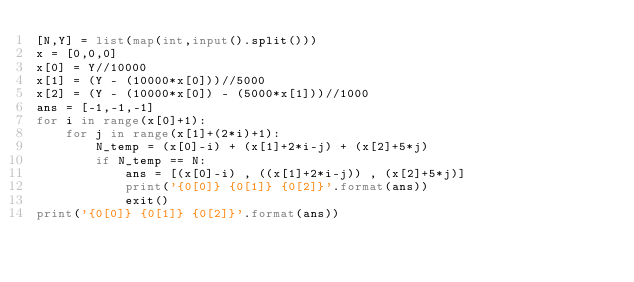<code> <loc_0><loc_0><loc_500><loc_500><_Python_>[N,Y] = list(map(int,input().split()))
x = [0,0,0]
x[0] = Y//10000
x[1] = (Y - (10000*x[0]))//5000
x[2] = (Y - (10000*x[0]) - (5000*x[1]))//1000
ans = [-1,-1,-1]
for i in range(x[0]+1):
    for j in range(x[1]+(2*i)+1):
        N_temp = (x[0]-i) + (x[1]+2*i-j) + (x[2]+5*j)
        if N_temp == N:
            ans = [(x[0]-i) , ((x[1]+2*i-j)) , (x[2]+5*j)]
            print('{0[0]} {0[1]} {0[2]}'.format(ans))
            exit()
print('{0[0]} {0[1]} {0[2]}'.format(ans))</code> 